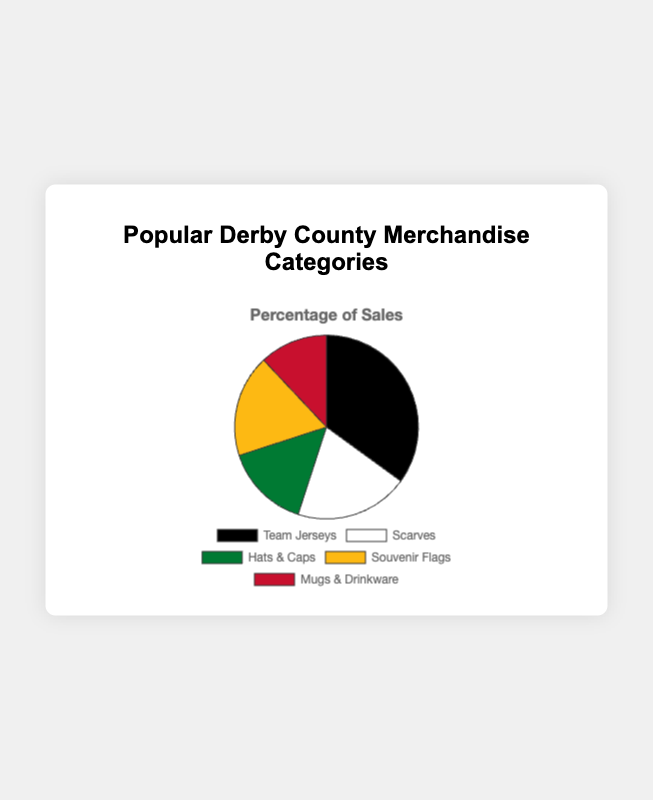Which merchandise category has the highest percentage of sales? The merchandise category with the highest percentage can be identified by looking for the largest slice of the pie chart. In this chart, "Team Jerseys" has the largest slice.
Answer: Team Jerseys Which merchandise categories have a sales percentage higher than 15%? By examining the pie chart, select slices that represent more than 15%. These are "Team Jerseys" (35%), "Scarves" (20%), and "Souvenir Flags" (18%).
Answer: Team Jerseys, Scarves, Souvenir Flags What is the difference in sales percentage between the highest and lowest merchandise categories? Identify the highest percentage (Team Jerseys at 35%) and the lowest percentage (Mugs & Drinkware at 12%). Subtract the lowest from the highest: 35% - 12% = 23%.
Answer: 23% If you combine the percentages of "Scarves" and "Hats & Caps", what is the total percentage? Add the percentages of "Scarves" (20%) and "Hats & Caps" (15%): 20% + 15% = 35%.
Answer: 35% Which merchandise category has the smallest percentage of sales? The smallest slice of the pie chart represents the smallest percentage. Here, "Mugs & Drinkware" has the smallest slice.
Answer: Mugs & Drinkware Are there more sales in "Scarves" than in "Souvenir Flags"? Compare the percentages of "Scarves" (20%) and "Souvenir Flags" (18%). Since 20% is greater than 18%, "Scarves" has more sales.
Answer: Yes How much more percentage of sales do "Team Jerseys" have compared to "Hats & Caps"? Subtract the percentage of "Hats & Caps" (15%) from "Team Jerseys" (35%): 35% - 15% = 20%.
Answer: 20% Which merchandise categories combined represent over half of the sales? Check combinations whose total is greater than 50%. "Team Jerseys" (35%) and "Scarves" (20%) together total 55%, greater than 50%. Other combinations can also work, such as adding "Hats & Caps" or "Souvenir Flags" to any.
Answer: Team Jerseys and Scarves Which merchandise category is represented by the color black? The largest slice of the pie chart, which is "Team Jerseys," is often represented by the color black.
Answer: Team Jerseys 